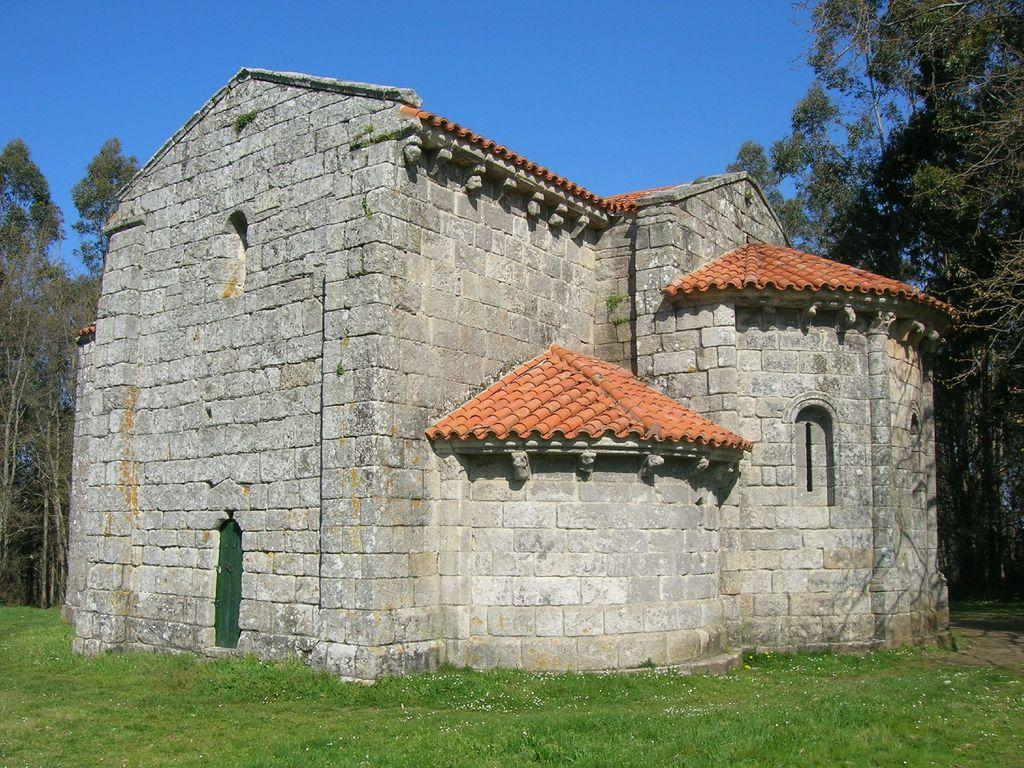What type of structure is visible in the image? There is a house in the image. What material is the house made of? The house is made of huge rocks. What is the landscape surrounding the house? The house is surrounded by grass. What other natural elements can be seen in the image? There are trees in the image. What is the color of the sky in the image? The sky is blue. Where is the self-portrait of the artist located in the image? There is no self-portrait of the artist present in the image. What type of vegetable is being served in the lunchroom in the image? There is no lunchroom or vegetable present in the image. 